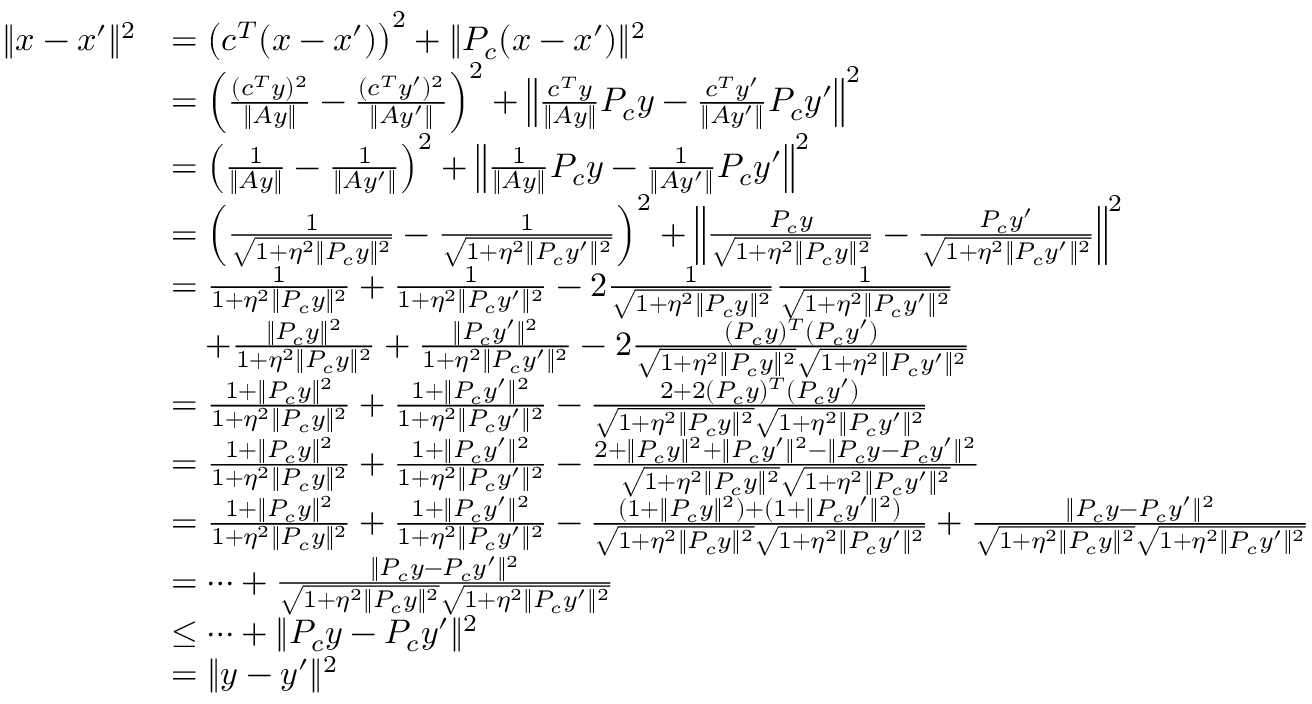Convert formula to latex. <formula><loc_0><loc_0><loc_500><loc_500>\begin{array} { r l } { \| x - x ^ { \prime } \| ^ { 2 } } & { = \left ( c ^ { T } ( x - x ^ { \prime } ) \right ) ^ { 2 } + \| P _ { c } ( x - x ^ { \prime } ) \| ^ { 2 } } \\ & { = \left ( \frac { ( c ^ { T } y ) ^ { 2 } } { \| A y \| } - \frac { ( c ^ { T } y ^ { \prime } ) ^ { 2 } } { \| A y ^ { \prime } \| } \right ) ^ { 2 } + \left \| \frac { c ^ { T } y } { \| A y \| } P _ { c } y - \frac { c ^ { T } y ^ { \prime } } { \| A y ^ { \prime } \| } P _ { c } y ^ { \prime } \right \| ^ { 2 } } \\ & { = \left ( \frac { 1 } { \| A y \| } - \frac { 1 } { \| A y ^ { \prime } \| } \right ) ^ { 2 } + \left \| \frac { 1 } { \| A y \| } P _ { c } y - \frac { 1 } { \| A y ^ { \prime } \| } P _ { c } y ^ { \prime } \right \| ^ { 2 } } \\ & { = \left ( \frac { 1 } { \sqrt { 1 + \eta ^ { 2 } \| P _ { c } y \| ^ { 2 } } } - \frac { 1 } { \sqrt { 1 + \eta ^ { 2 } \| P _ { c } y ^ { \prime } \| ^ { 2 } } } \right ) ^ { 2 } + \left \| \frac { P _ { c } y } { \sqrt { 1 + \eta ^ { 2 } \| P _ { c } y \| ^ { 2 } } } - \frac { P _ { c } y ^ { \prime } } { \sqrt { 1 + \eta ^ { 2 } \| P _ { c } y ^ { \prime } \| ^ { 2 } } } \right \| ^ { 2 } } \\ & { = \frac { 1 } { 1 + \eta ^ { 2 } \| P _ { c } y \| ^ { 2 } } + \frac { 1 } { 1 + \eta ^ { 2 } \| P _ { c } y ^ { \prime } \| ^ { 2 } } - 2 \frac { 1 } { \sqrt { 1 + \eta ^ { 2 } \| P _ { c } y \| ^ { 2 } } } \frac { 1 } { \sqrt { 1 + \eta ^ { 2 } \| P _ { c } y ^ { \prime } \| ^ { 2 } } } } \\ & { \quad + \frac { \| P _ { c } y \| ^ { 2 } } { 1 + \eta ^ { 2 } \| P _ { c } y \| ^ { 2 } } + \frac { \| P _ { c } y ^ { \prime } \| ^ { 2 } } { 1 + \eta ^ { 2 } \| P _ { c } y ^ { \prime } \| ^ { 2 } } - 2 \frac { ( P _ { c } y ) ^ { T } ( P _ { c } y ^ { \prime } ) } { \sqrt { 1 + \eta ^ { 2 } \| P _ { c } y \| ^ { 2 } } \sqrt { 1 + \eta ^ { 2 } \| P _ { c } y ^ { \prime } \| ^ { 2 } } } } \\ & { = \frac { 1 + \| P _ { c } y \| ^ { 2 } } { 1 + \eta ^ { 2 } \| P _ { c } y \| ^ { 2 } } + \frac { 1 + \| P _ { c } y ^ { \prime } \| ^ { 2 } } { 1 + \eta ^ { 2 } \| P _ { c } y ^ { \prime } \| ^ { 2 } } - \frac { 2 + 2 ( P _ { c } y ) ^ { T } ( P _ { c } y ^ { \prime } ) } { \sqrt { 1 + \eta ^ { 2 } \| P _ { c } y \| ^ { 2 } } \sqrt { 1 + \eta ^ { 2 } \| P _ { c } y ^ { \prime } \| ^ { 2 } } } } \\ & { = \frac { 1 + \| P _ { c } y \| ^ { 2 } } { 1 + \eta ^ { 2 } \| P _ { c } y \| ^ { 2 } } + \frac { 1 + \| P _ { c } y ^ { \prime } \| ^ { 2 } } { 1 + \eta ^ { 2 } \| P _ { c } y ^ { \prime } \| ^ { 2 } } - \frac { 2 + \| P _ { c } y \| ^ { 2 } + \| P _ { c } y ^ { \prime } \| ^ { 2 } - \| P _ { c } y - P _ { c } y ^ { \prime } \| ^ { 2 } } { \sqrt { 1 + \eta ^ { 2 } \| P _ { c } y \| ^ { 2 } } \sqrt { 1 + \eta ^ { 2 } \| P _ { c } y ^ { \prime } \| ^ { 2 } } } } \\ & { = \frac { 1 + \| P _ { c } y \| ^ { 2 } } { 1 + \eta ^ { 2 } \| P _ { c } y \| ^ { 2 } } + \frac { 1 + \| P _ { c } y ^ { \prime } \| ^ { 2 } } { 1 + \eta ^ { 2 } \| P _ { c } y ^ { \prime } \| ^ { 2 } } - \frac { ( 1 + \| P _ { c } y \| ^ { 2 } ) + ( 1 + \| P _ { c } y ^ { \prime } \| ^ { 2 } ) } { \sqrt { 1 + \eta ^ { 2 } \| P _ { c } y \| ^ { 2 } } \sqrt { 1 + \eta ^ { 2 } \| P _ { c } y ^ { \prime } \| ^ { 2 } } } + \frac { \| P _ { c } y - P _ { c } y ^ { \prime } \| ^ { 2 } } { \sqrt { 1 + \eta ^ { 2 } \| P _ { c } y \| ^ { 2 } } \sqrt { 1 + \eta ^ { 2 } \| P _ { c } y ^ { \prime } \| ^ { 2 } } } } \\ & { = \dots + \frac { \| P _ { c } y - P _ { c } y ^ { \prime } \| ^ { 2 } } { \sqrt { 1 + \eta ^ { 2 } \| P _ { c } y \| ^ { 2 } } \sqrt { 1 + \eta ^ { 2 } \| P _ { c } y ^ { \prime } \| ^ { 2 } } } } \\ & { \leq \dots + \| P _ { c } y - P _ { c } y ^ { \prime } \| ^ { 2 } } \\ & { = \| y - y ^ { \prime } \| ^ { 2 } } \end{array}</formula> 